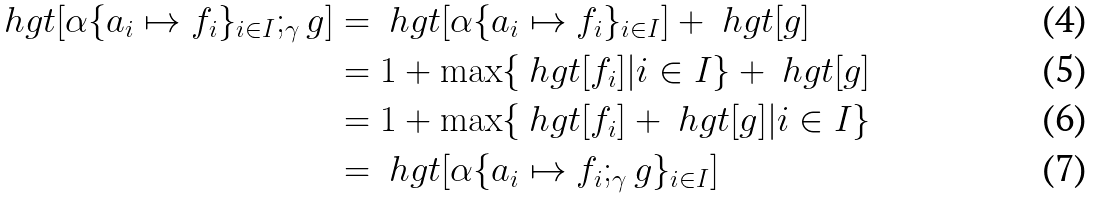Convert formula to latex. <formula><loc_0><loc_0><loc_500><loc_500>\ h g t [ \alpha \{ a _ { i } \mapsto f _ { i } \} _ { i \in I } ; _ { \gamma } g ] & = \ h g t [ \alpha \{ a _ { i } \mapsto f _ { i } \} _ { i \in I } ] + \ h g t [ g ] \\ & = 1 + \max \{ \ h g t [ f _ { i } ] | i \in I \} + \ h g t [ g ] \\ & = 1 + \max \{ \ h g t [ f _ { i } ] + \ h g t [ g ] | i \in I \} \\ & = \ h g t [ \alpha \{ a _ { i } \mapsto f _ { i } ; _ { \gamma } g \} _ { i \in I } ]</formula> 